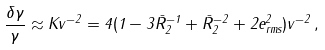<formula> <loc_0><loc_0><loc_500><loc_500>\frac { \delta \gamma } { \gamma } \approx K v ^ { - 2 } = 4 ( 1 - 3 \bar { R } _ { 2 } ^ { - 1 } + \bar { R } _ { 2 } ^ { - 2 } + 2 e _ { r m s } ^ { 2 } ) v ^ { - 2 } \, ,</formula> 